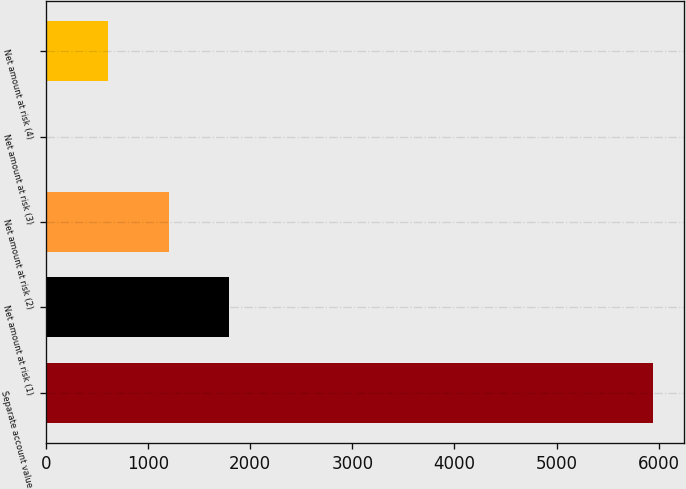Convert chart. <chart><loc_0><loc_0><loc_500><loc_500><bar_chart><fcel>Separate account value<fcel>Net amount at risk (1)<fcel>Net amount at risk (2)<fcel>Net amount at risk (3)<fcel>Net amount at risk (4)<nl><fcel>5947<fcel>1795.3<fcel>1202.2<fcel>16<fcel>609.1<nl></chart> 